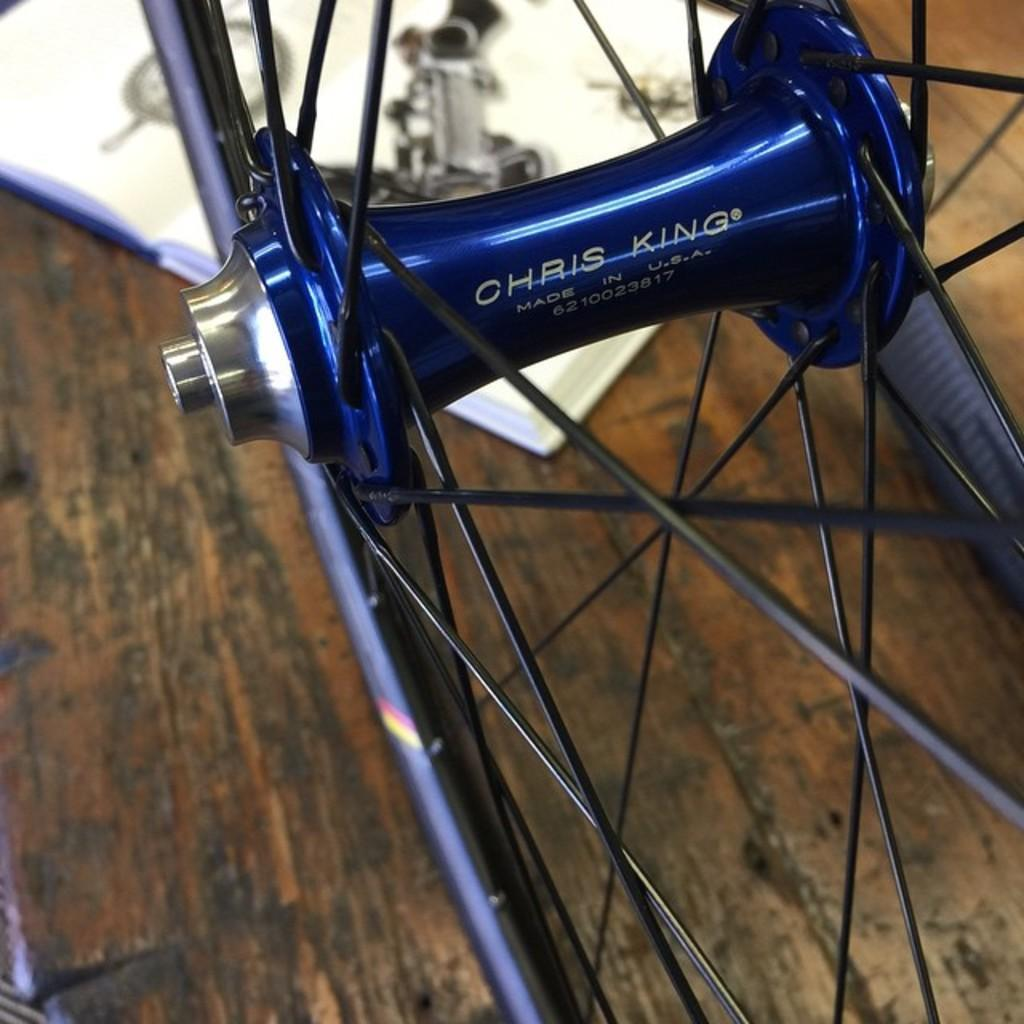What is the main object in the image? There is a wheel in the image. Can you describe the colors of the wheel? The wheel is blue and black in color. What is the surface on which the wheel is placed? The wheel is on a brown and black colored surface. What other object can be seen on the surface? There is a white colored object on the surface. How many people are in jail in the image? There is no reference to a jail or any people in the image, so it is not possible to answer that question. 